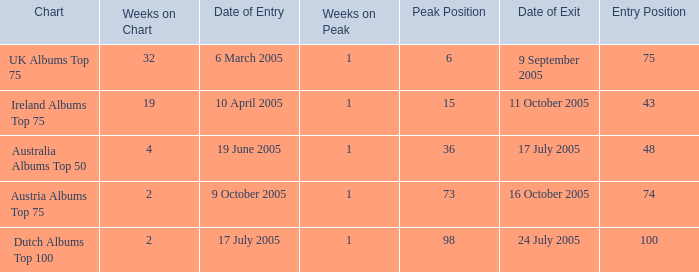What is the date of entry for the UK Albums Top 75 chart? 6 March 2005. 